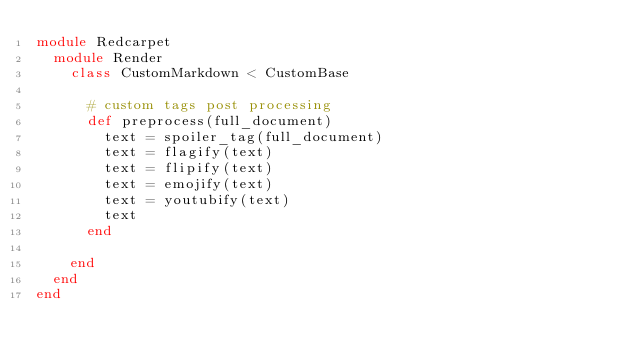Convert code to text. <code><loc_0><loc_0><loc_500><loc_500><_Ruby_>module Redcarpet
  module Render
    class CustomMarkdown < CustomBase

      # custom tags post processing
      def preprocess(full_document)
        text = spoiler_tag(full_document)
        text = flagify(text)
        text = flipify(text)
        text = emojify(text)
        text = youtubify(text)
        text
      end

    end
  end
end
</code> 